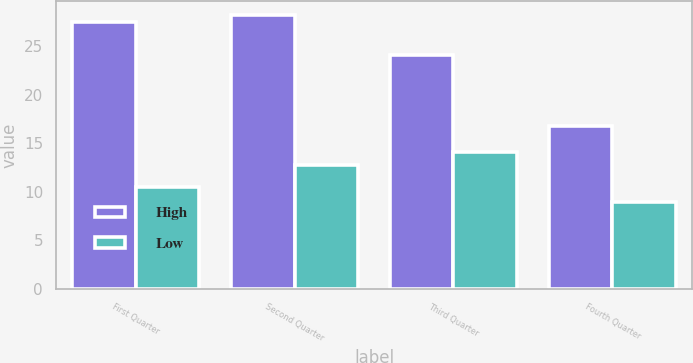<chart> <loc_0><loc_0><loc_500><loc_500><stacked_bar_chart><ecel><fcel>First Quarter<fcel>Second Quarter<fcel>Third Quarter<fcel>Fourth Quarter<nl><fcel>High<fcel>27.5<fcel>28.23<fcel>24.1<fcel>16.78<nl><fcel>Low<fcel>10.5<fcel>12.8<fcel>14.14<fcel>8.96<nl></chart> 